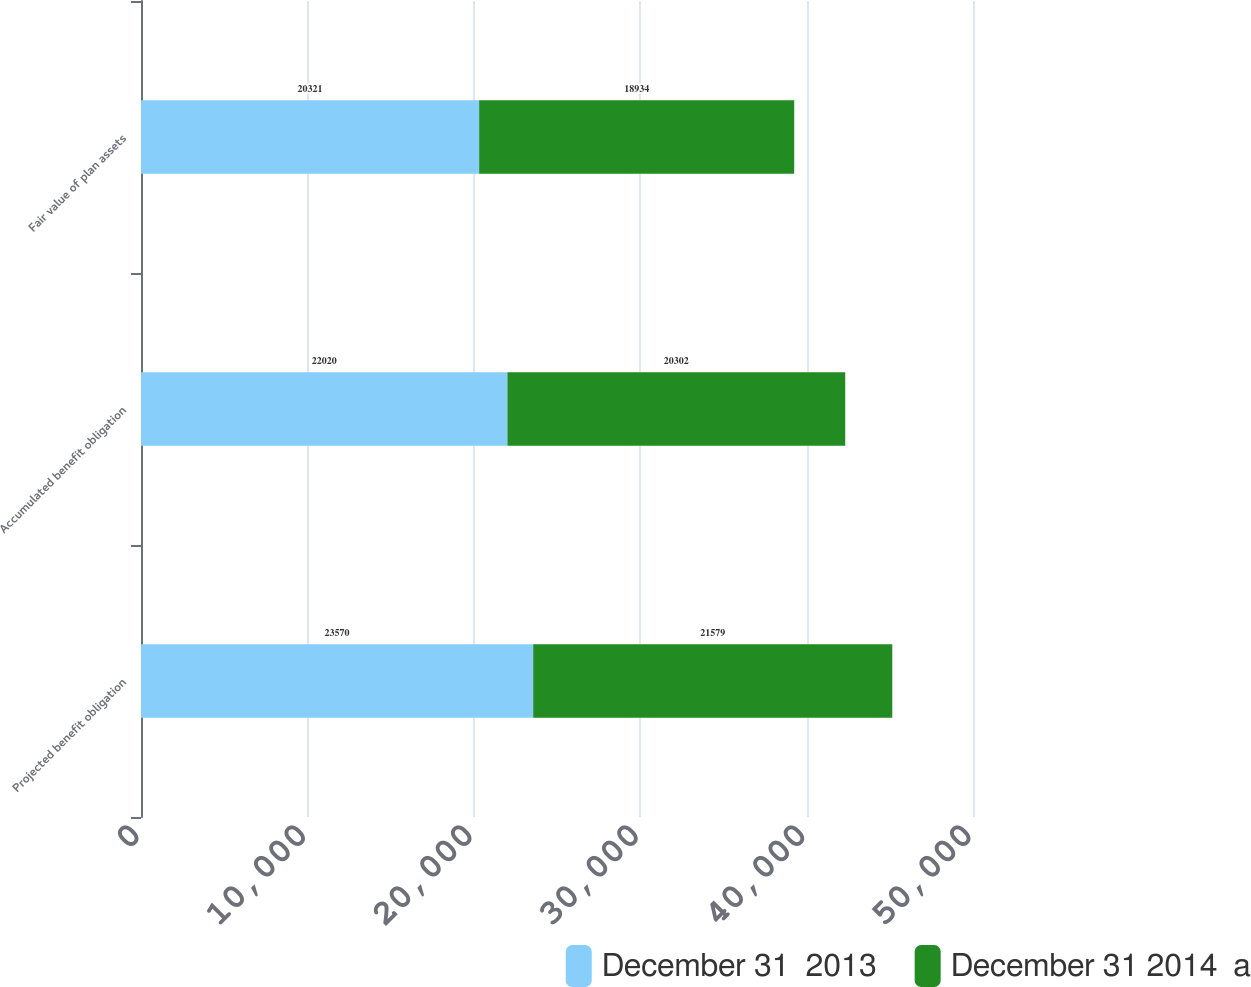<chart> <loc_0><loc_0><loc_500><loc_500><stacked_bar_chart><ecel><fcel>Projected benefit obligation<fcel>Accumulated benefit obligation<fcel>Fair value of plan assets<nl><fcel>December 31  2013<fcel>23570<fcel>22020<fcel>20321<nl><fcel>December 31 2014  a<fcel>21579<fcel>20302<fcel>18934<nl></chart> 